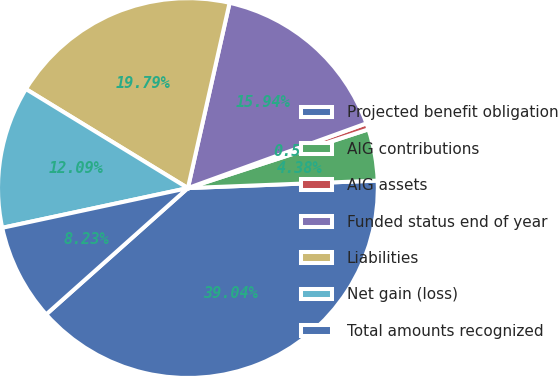<chart> <loc_0><loc_0><loc_500><loc_500><pie_chart><fcel>Projected benefit obligation<fcel>AIG contributions<fcel>AIG assets<fcel>Funded status end of year<fcel>Liabilities<fcel>Net gain (loss)<fcel>Total amounts recognized<nl><fcel>39.04%<fcel>4.38%<fcel>0.53%<fcel>15.94%<fcel>19.79%<fcel>12.09%<fcel>8.23%<nl></chart> 